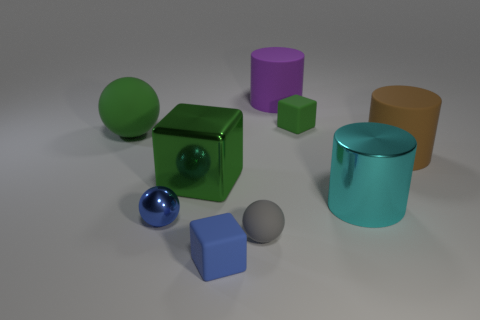Subtract all green cubes. How many cubes are left? 1 Subtract 2 cylinders. How many cylinders are left? 1 Add 1 brown matte blocks. How many objects exist? 10 Subtract all brown cylinders. How many cylinders are left? 2 Subtract all cylinders. How many objects are left? 6 Subtract all green balls. How many blue cubes are left? 1 Subtract all green cylinders. Subtract all big purple cylinders. How many objects are left? 8 Add 1 cyan cylinders. How many cyan cylinders are left? 2 Add 8 big green cylinders. How many big green cylinders exist? 8 Subtract 0 yellow cubes. How many objects are left? 9 